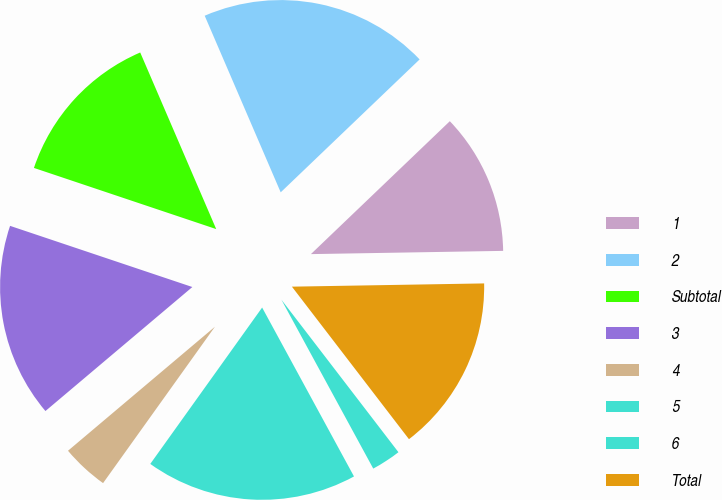<chart> <loc_0><loc_0><loc_500><loc_500><pie_chart><fcel>1<fcel>2<fcel>Subtotal<fcel>3<fcel>4<fcel>5<fcel>6<fcel>Total<nl><fcel>11.88%<fcel>19.32%<fcel>13.38%<fcel>16.31%<fcel>3.96%<fcel>17.81%<fcel>2.49%<fcel>14.85%<nl></chart> 